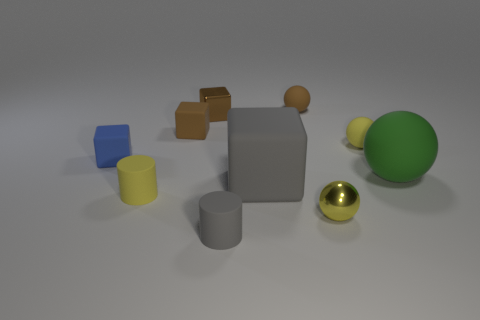How many things are either brown matte objects that are right of the tiny gray rubber thing or small yellow things?
Your answer should be compact. 4. What is the size of the green ball that is made of the same material as the large cube?
Offer a very short reply. Large. How many matte balls are the same color as the big cube?
Keep it short and to the point. 0. What number of large things are either gray matte cubes or blue matte blocks?
Ensure brevity in your answer.  1. The matte cylinder that is the same color as the big cube is what size?
Give a very brief answer. Small. Are there any blue things made of the same material as the small gray cylinder?
Offer a terse response. Yes. What is the material of the cylinder that is on the left side of the gray rubber cylinder?
Offer a very short reply. Rubber. Does the matte block in front of the large rubber ball have the same color as the tiny rubber thing that is to the right of the small brown rubber ball?
Your answer should be very brief. No. What color is the metal ball that is the same size as the yellow matte ball?
Keep it short and to the point. Yellow. How many other things are the same shape as the small brown metal object?
Provide a succinct answer. 3. 